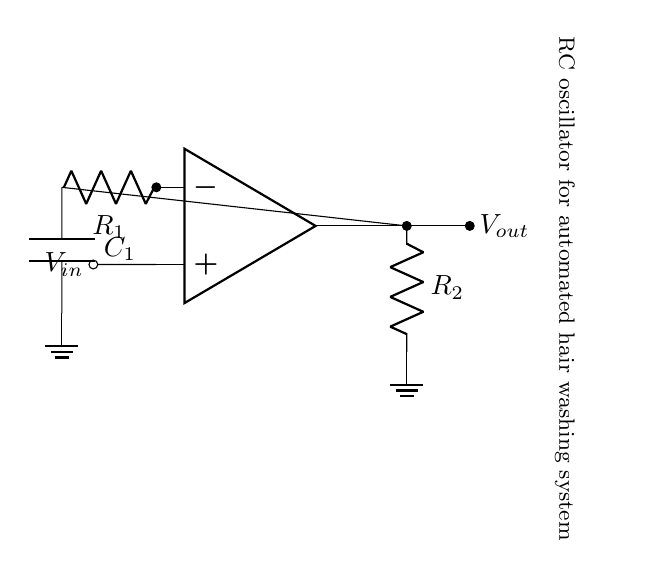What components are present in the circuit? The circuit contains a resistor labeled R1, a capacitor labeled C1, another resistor labeled R2, and an operational amplifier symbol.
Answer: R1, C1, R2, op amp What is the role of the operational amplifier in this circuit? The operational amplifier amplifies the voltage difference between its input terminals, enabling the RC circuit to oscillate and generate timed pulses.
Answer: Amplifier What is the function of the capacitor in this RC oscillator circuit? The capacitor stores and releases electrical energy, which is essential for creating the timing intervals needed for oscillation.
Answer: Timing How many resistors are in the RC oscillator circuit? There are two resistors in the circuit: R1 and R2.
Answer: Two What is the relationship between R1 and C1 in determining the oscillation frequency? The oscillation frequency is inversely proportional to the time constant formed by R1 and C1, which is calculated as the product of R1 and C1.
Answer: Inverse How does the output voltage relate to the input voltage in this circuit? The output voltage is a function of the gain of the operational amplifier and the input voltage across R1, influenced by the charging and discharging behavior of C1.
Answer: Function of gain What happens if R1 is increased in value? Increasing R1 will increase the time constant (R1 times C1), resulting in a decrease in the oscillation frequency, causing longer intervals between pulses.
Answer: Decrease frequency 